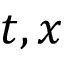Convert formula to latex. <formula><loc_0><loc_0><loc_500><loc_500>t , x</formula> 